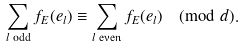<formula> <loc_0><loc_0><loc_500><loc_500>\sum _ { l \text { odd} } f _ { E } ( e _ { l } ) \equiv \sum _ { l \text { even} } f _ { E } ( e _ { l } ) \pmod { d } .</formula> 